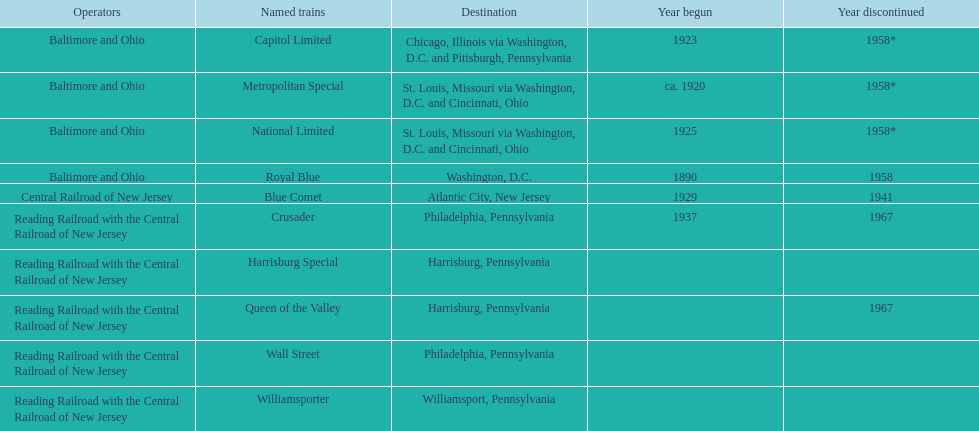What was the first train to begin service? Royal Blue. 